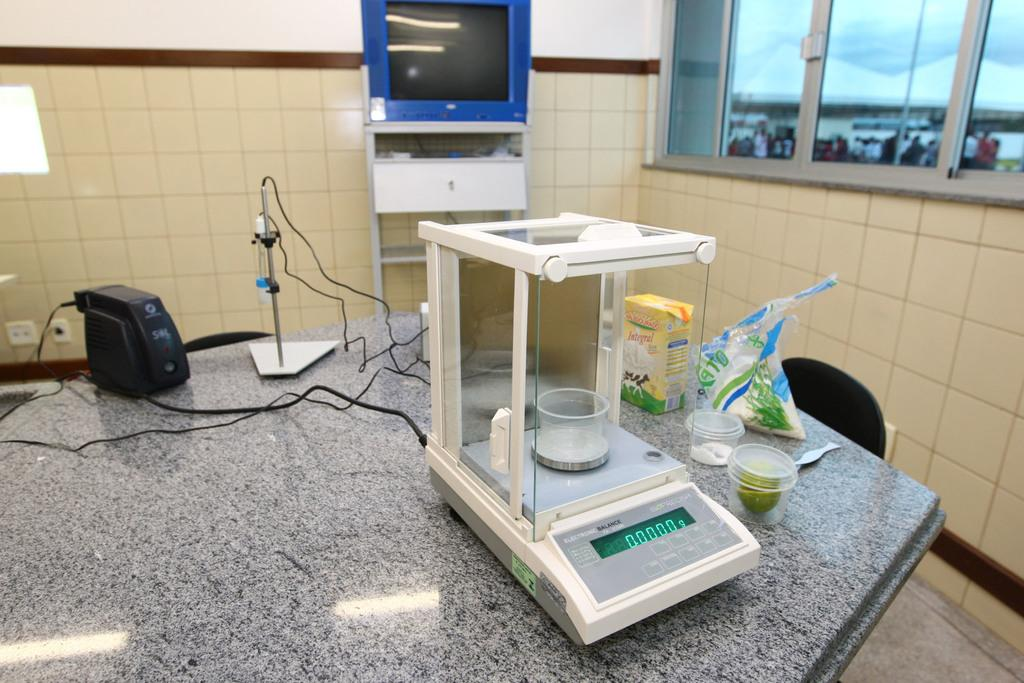Provide a one-sentence caption for the provided image. An electronic balance scale that is set at zero grams. 